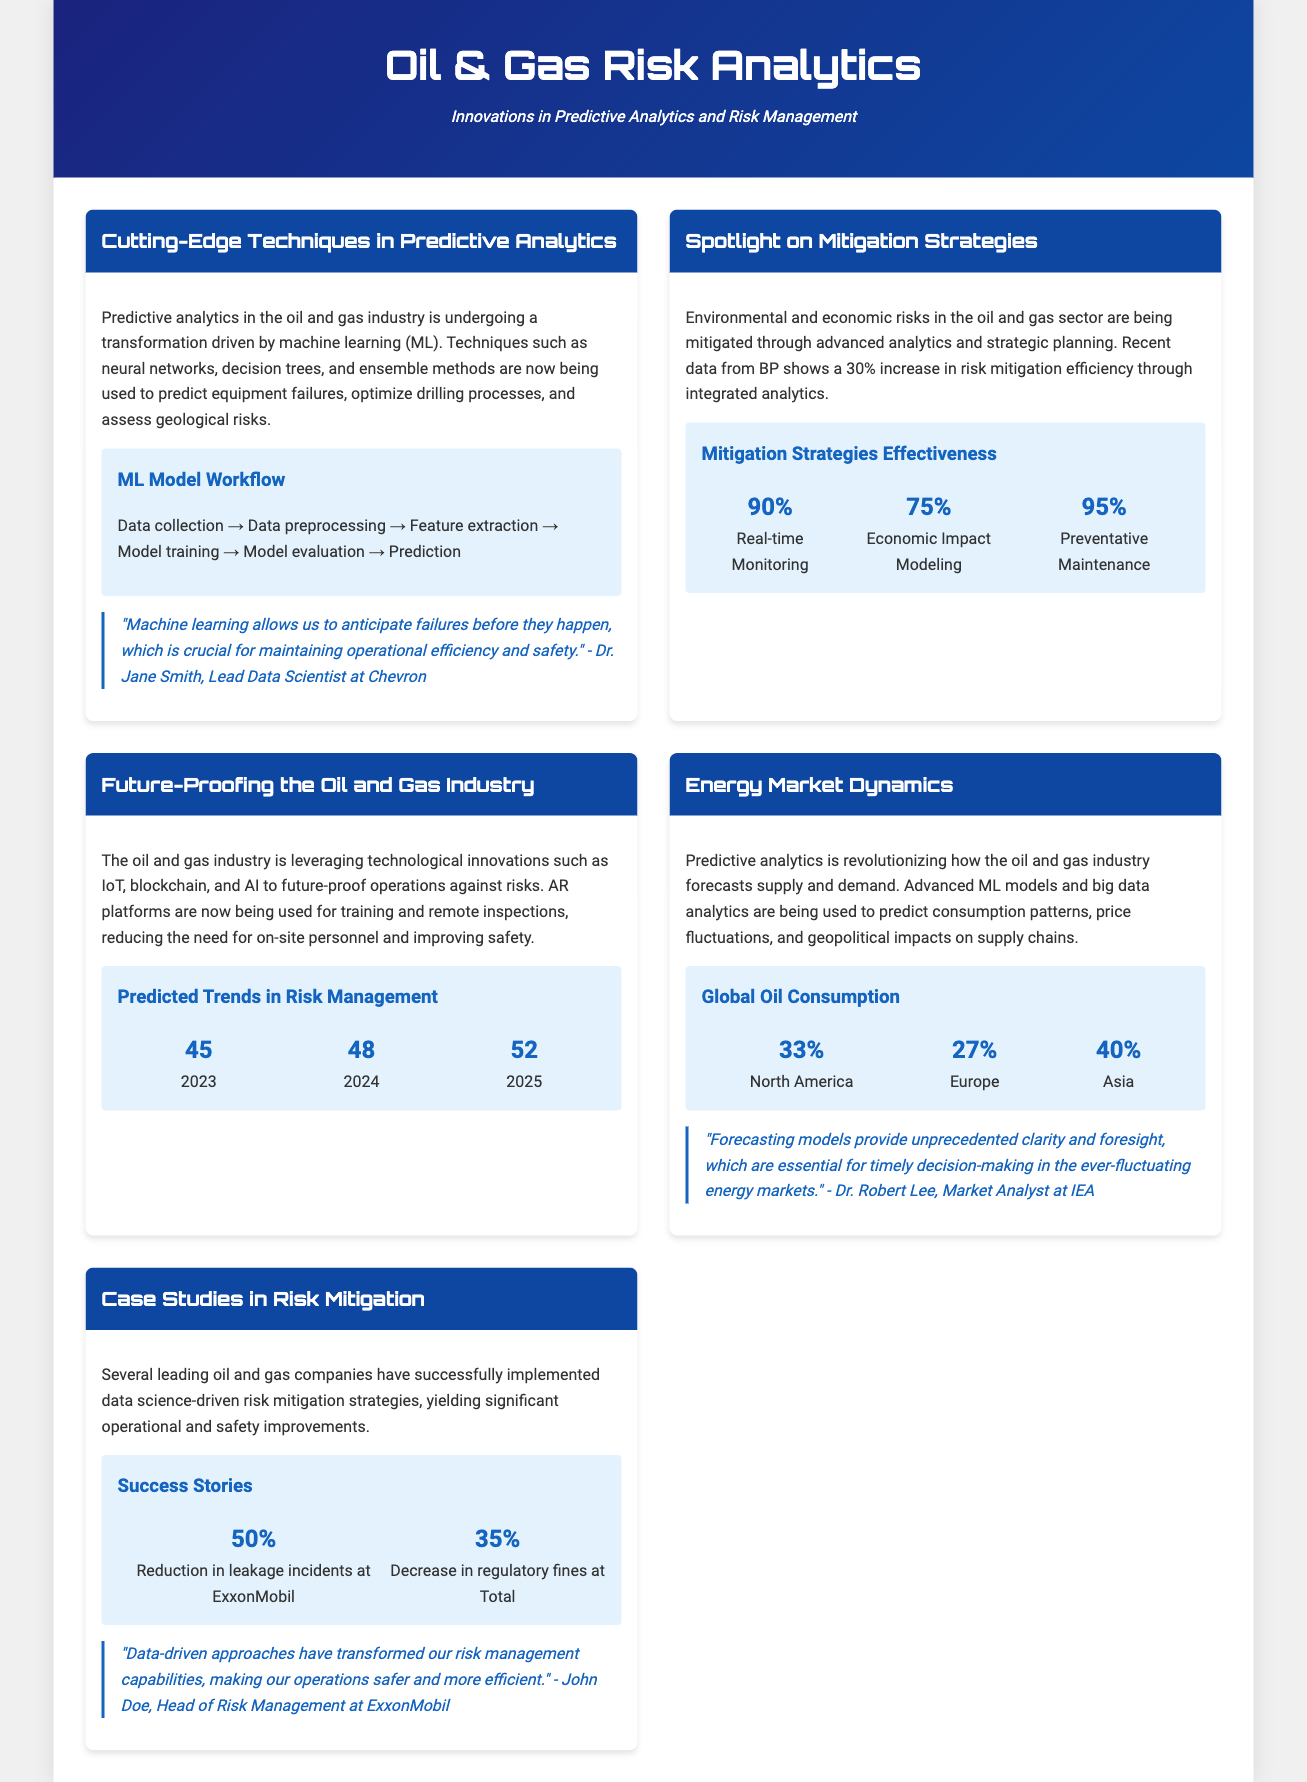What percentage increase in risk mitigation efficiency is reported by BP? BP reports a 30% increase in risk mitigation efficiency through integrated analytics.
Answer: 30% Which machine learning technique is mentioned for predicting equipment failures? Predictive analytics techniques such as neural networks are mentioned for predicting equipment failures.
Answer: Neural networks What is the economic impact modeling effectiveness percentage? The effectiveness of economic impact modeling is indicated as 75% in the document.
Answer: 75% What year is projected to have the highest predicted trend in risk management according to the infographic? The document states that 2025 will have the highest predicted trend in risk management at 52.
Answer: 2025 Who is quoted regarding the importance of forecasting models in decision-making? The document quotes Dr. Robert Lee as emphasizing the significance of forecasting models for decision-making.
Answer: Dr. Robert Lee What company reported a 50% reduction in leakage incidents? ExxonMobil is the company mentioned that achieved a 50% reduction in leakage incidents.
Answer: ExxonMobil How much decrease in regulatory fines was reported by Total? Total reported a 35% decrease in regulatory fines due to their risk mitigation strategies.
Answer: 35% What is the main theme of the magazine? The main theme highlights innovations in predictive analytics and risk management in the oil and gas industry.
Answer: Innovations in predictive analytics and risk management What type of graphics are used to represent global oil consumption? The document describes infographics being used to visually represent global oil consumption distribution.
Answer: Infographics 